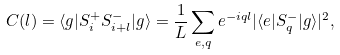Convert formula to latex. <formula><loc_0><loc_0><loc_500><loc_500>C ( l ) = \langle g | S _ { i } ^ { + } S _ { i + l } ^ { - } | g \rangle = \frac { 1 } { L } \sum _ { e , q } e ^ { - i q l } | \langle e | S _ { q } ^ { - } | g \rangle | ^ { 2 } ,</formula> 